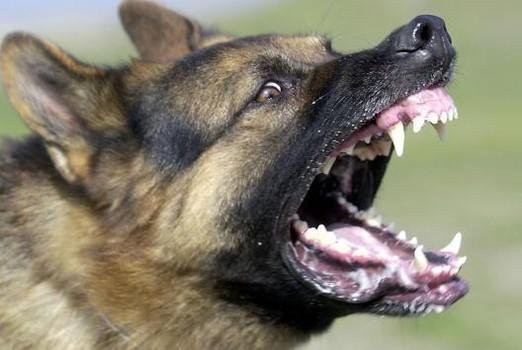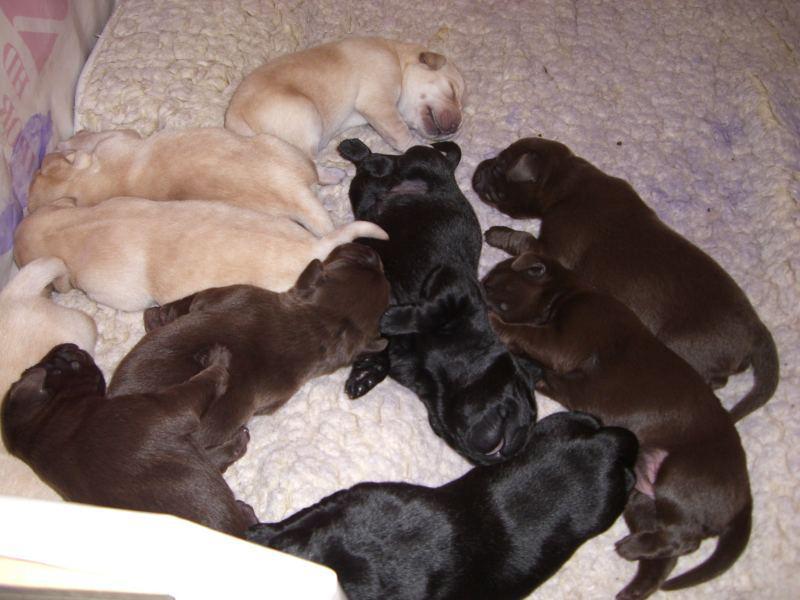The first image is the image on the left, the second image is the image on the right. For the images shown, is this caption "The right image contains more than one dog, and the left image features a dog with fangs bared in a snarl." true? Answer yes or no. Yes. The first image is the image on the left, the second image is the image on the right. Given the left and right images, does the statement "There is no more than two dogs in the right image." hold true? Answer yes or no. No. 